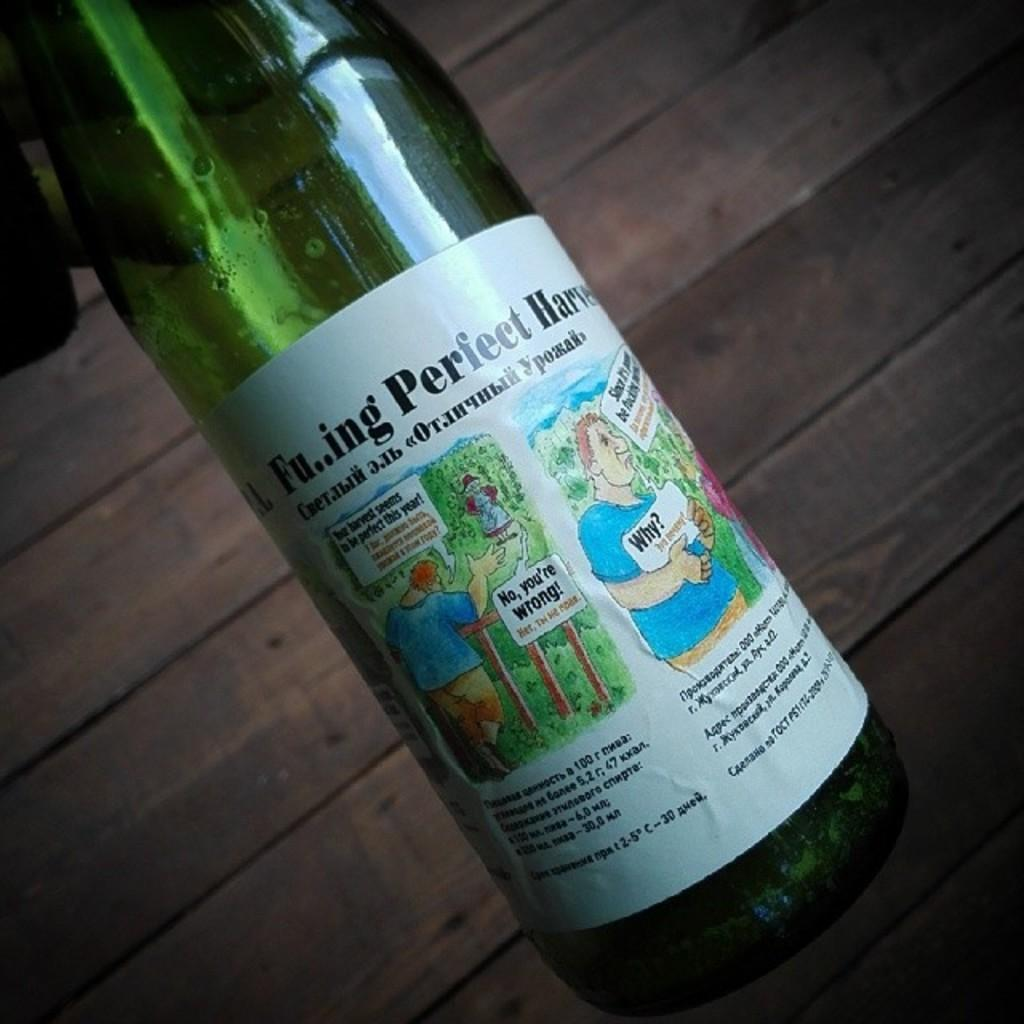<image>
Summarize the visual content of the image. A wine bottle has a drawing of a little sign that says "No, you're wrong." 